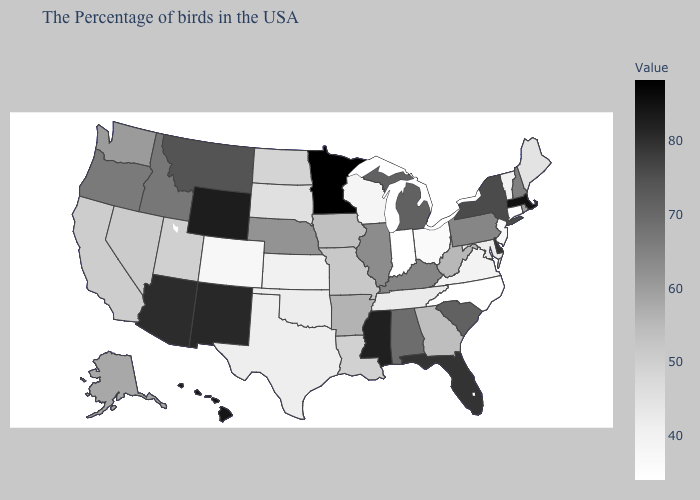Does Illinois have a lower value than Montana?
Short answer required. Yes. Among the states that border Indiana , which have the lowest value?
Short answer required. Ohio. Does Iowa have a higher value than Michigan?
Answer briefly. No. Does the map have missing data?
Write a very short answer. No. Does North Carolina have the lowest value in the USA?
Keep it brief. Yes. Is the legend a continuous bar?
Quick response, please. Yes. Does Washington have a higher value than Michigan?
Concise answer only. No. 